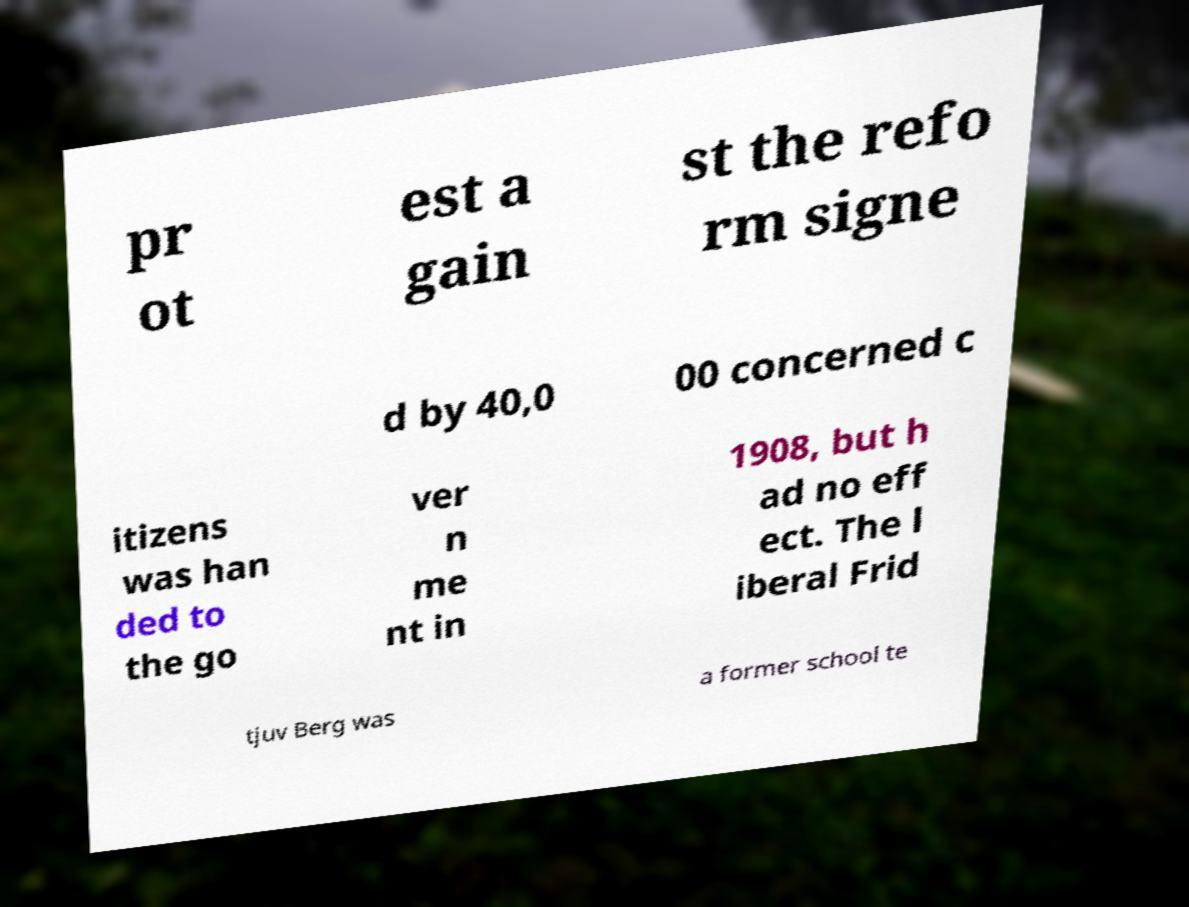There's text embedded in this image that I need extracted. Can you transcribe it verbatim? pr ot est a gain st the refo rm signe d by 40,0 00 concerned c itizens was han ded to the go ver n me nt in 1908, but h ad no eff ect. The l iberal Frid tjuv Berg was a former school te 